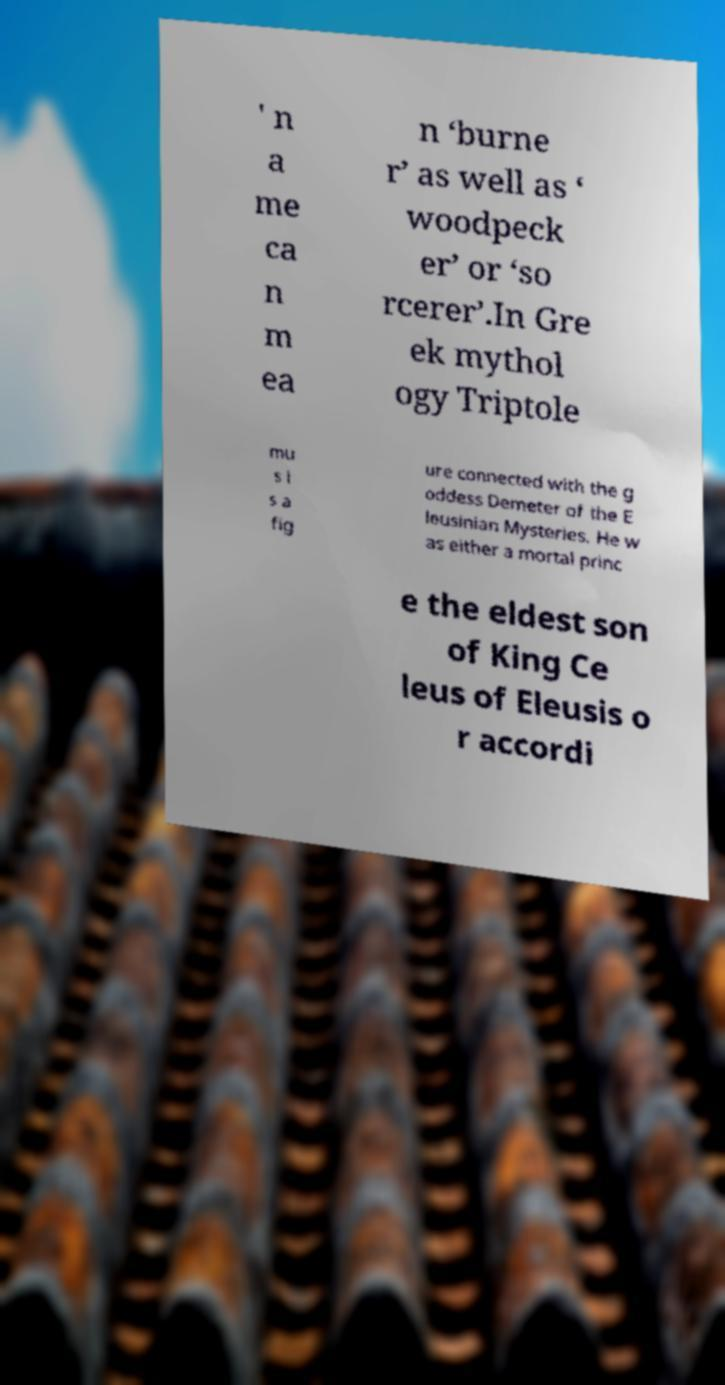Could you extract and type out the text from this image? ' n a me ca n m ea n ‘burne r’ as well as ‘ woodpeck er’ or ‘so rcerer’.In Gre ek mythol ogy Triptole mu s i s a fig ure connected with the g oddess Demeter of the E leusinian Mysteries. He w as either a mortal princ e the eldest son of King Ce leus of Eleusis o r accordi 